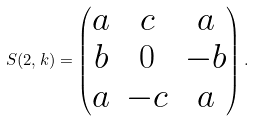<formula> <loc_0><loc_0><loc_500><loc_500>S ( 2 , k ) = \begin{pmatrix} a & c & a \\ b & 0 & - b \\ a & - c & a \end{pmatrix} .</formula> 